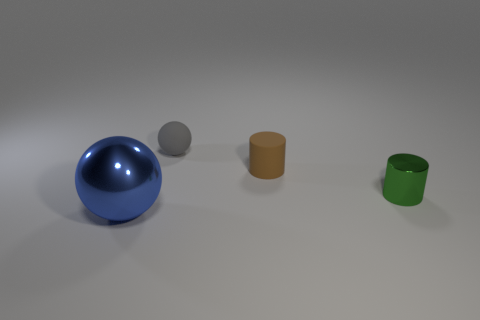Add 1 tiny spheres. How many objects exist? 5 Subtract 2 balls. How many balls are left? 0 Subtract all blue balls. How many balls are left? 1 Subtract all green shiny cylinders. Subtract all brown objects. How many objects are left? 2 Add 2 green metal cylinders. How many green metal cylinders are left? 3 Add 4 rubber cylinders. How many rubber cylinders exist? 5 Subtract 0 green blocks. How many objects are left? 4 Subtract all purple balls. Subtract all purple cylinders. How many balls are left? 2 